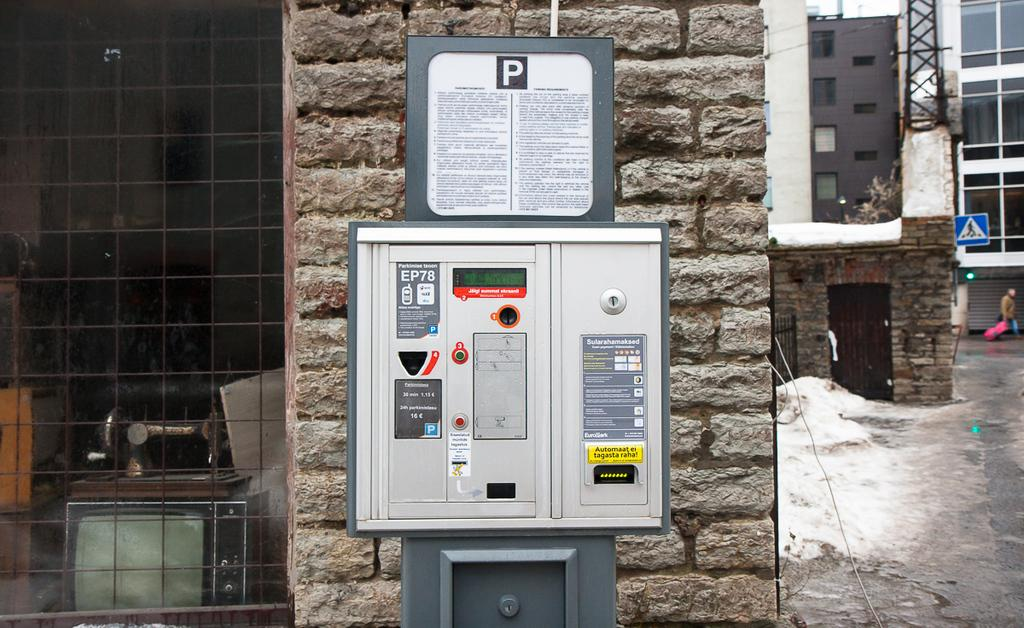<image>
Summarize the visual content of the image. a box with EP78 written in the top left 